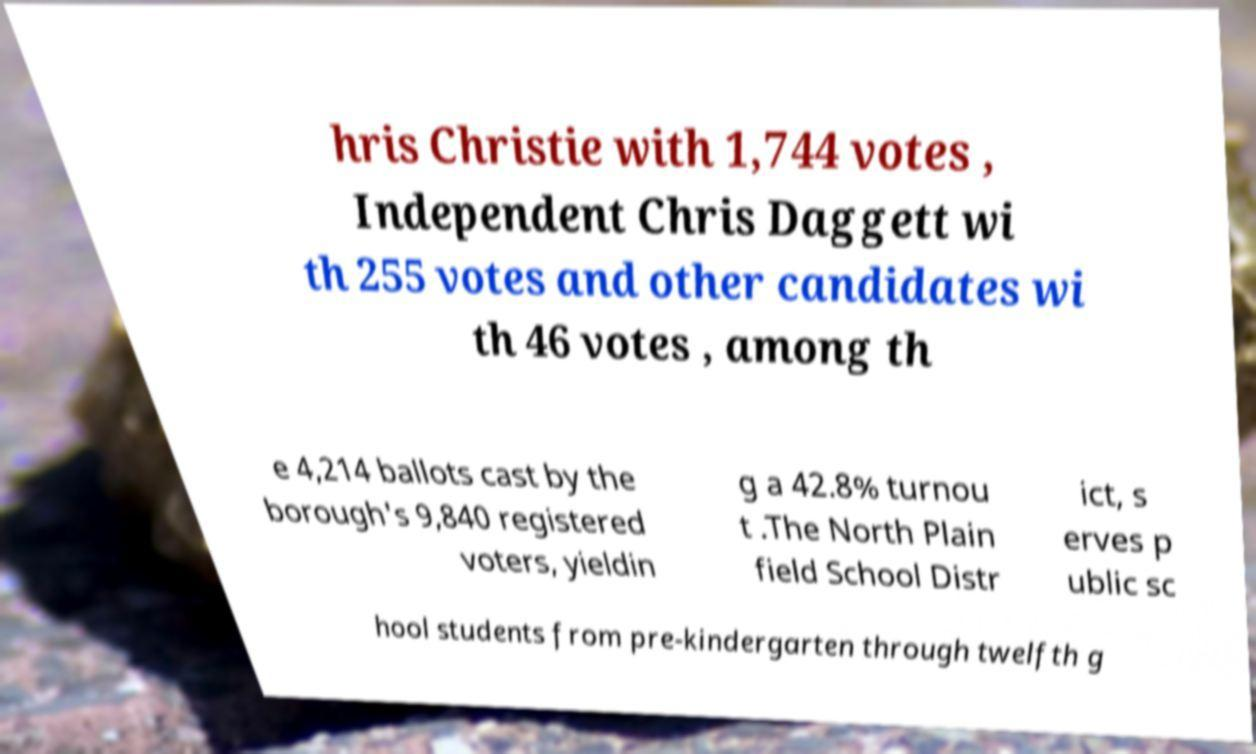Can you accurately transcribe the text from the provided image for me? hris Christie with 1,744 votes , Independent Chris Daggett wi th 255 votes and other candidates wi th 46 votes , among th e 4,214 ballots cast by the borough's 9,840 registered voters, yieldin g a 42.8% turnou t .The North Plain field School Distr ict, s erves p ublic sc hool students from pre-kindergarten through twelfth g 